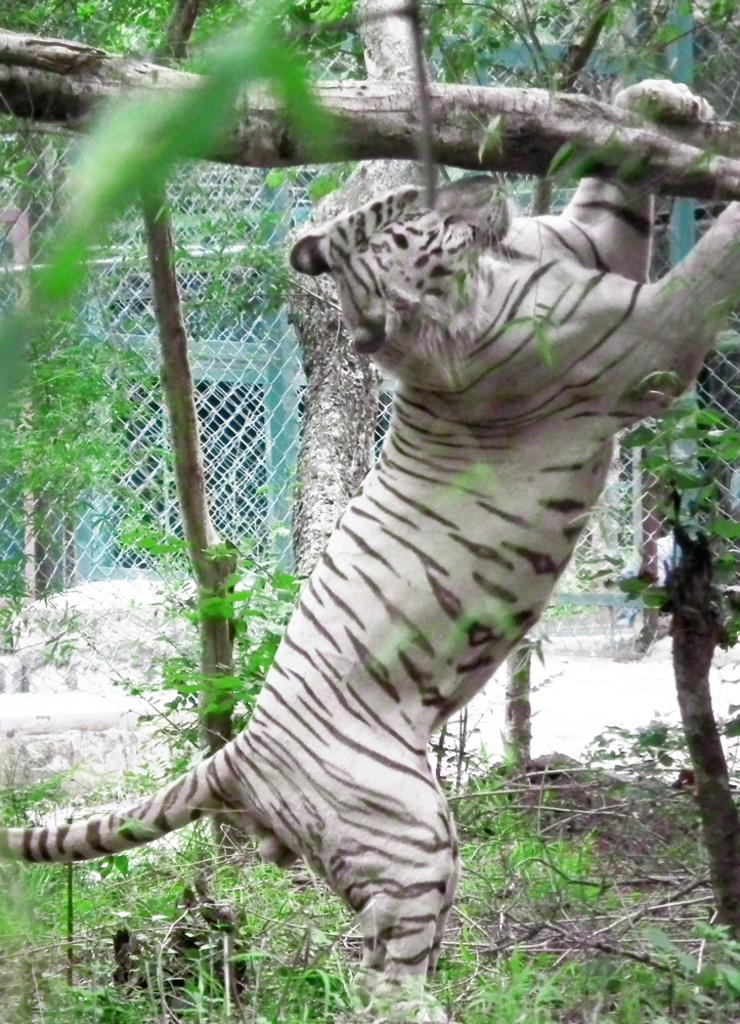What type of animal is in the image? There is a tiger in the image. What type of natural vegetation is visible in the image? There are trees in the image. What is present in the background of the image? There is a mesh fencing in the background of the image. What type of spy equipment can be seen in the image? There is no spy equipment present in the image. What type of bread is being used to feed the tiger in the image? There is no bread present in the image. 